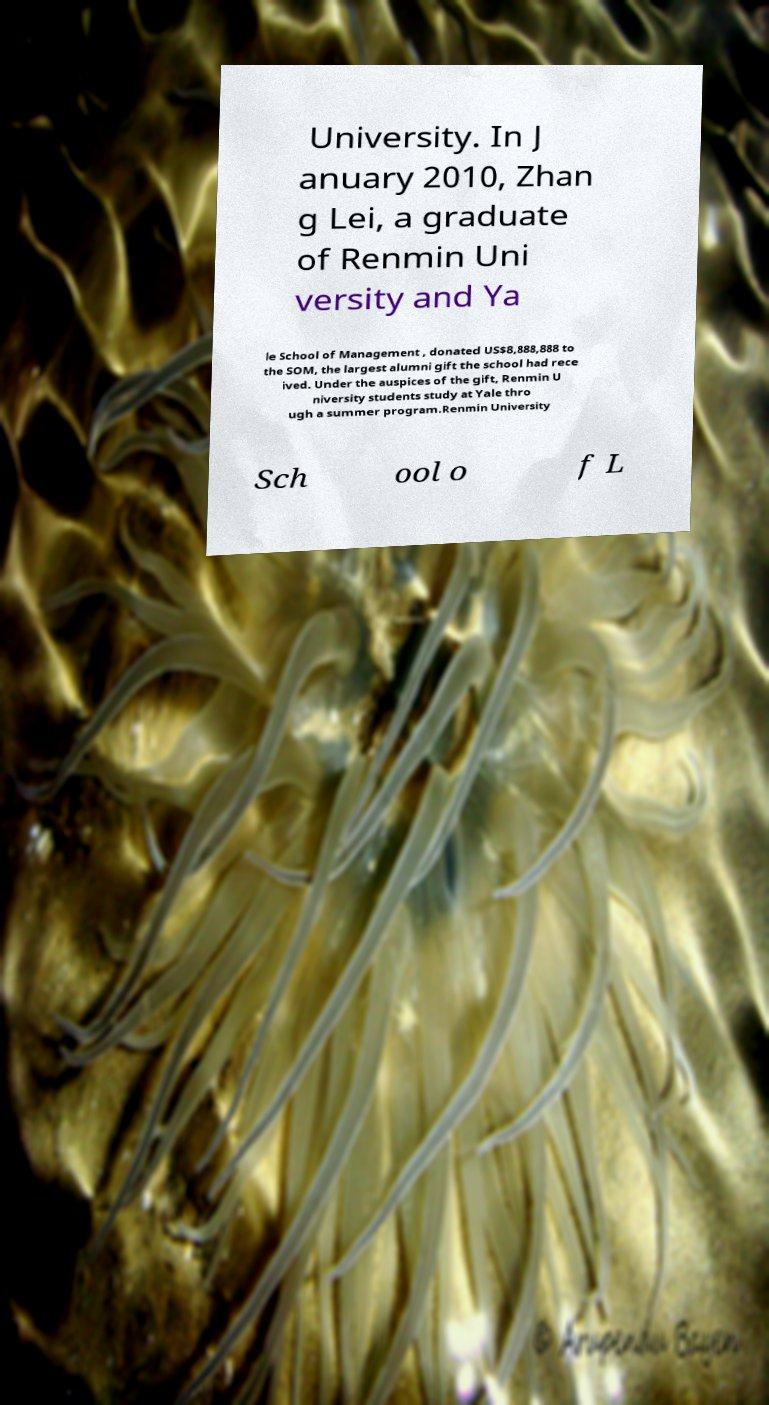Can you read and provide the text displayed in the image?This photo seems to have some interesting text. Can you extract and type it out for me? University. In J anuary 2010, Zhan g Lei, a graduate of Renmin Uni versity and Ya le School of Management , donated US$8,888,888 to the SOM, the largest alumni gift the school had rece ived. Under the auspices of the gift, Renmin U niversity students study at Yale thro ugh a summer program.Renmin University Sch ool o f L 